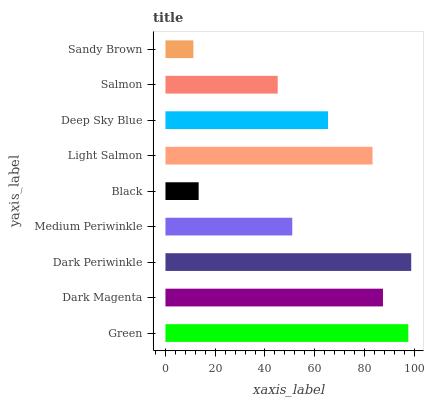Is Sandy Brown the minimum?
Answer yes or no. Yes. Is Dark Periwinkle the maximum?
Answer yes or no. Yes. Is Dark Magenta the minimum?
Answer yes or no. No. Is Dark Magenta the maximum?
Answer yes or no. No. Is Green greater than Dark Magenta?
Answer yes or no. Yes. Is Dark Magenta less than Green?
Answer yes or no. Yes. Is Dark Magenta greater than Green?
Answer yes or no. No. Is Green less than Dark Magenta?
Answer yes or no. No. Is Deep Sky Blue the high median?
Answer yes or no. Yes. Is Deep Sky Blue the low median?
Answer yes or no. Yes. Is Dark Magenta the high median?
Answer yes or no. No. Is Green the low median?
Answer yes or no. No. 